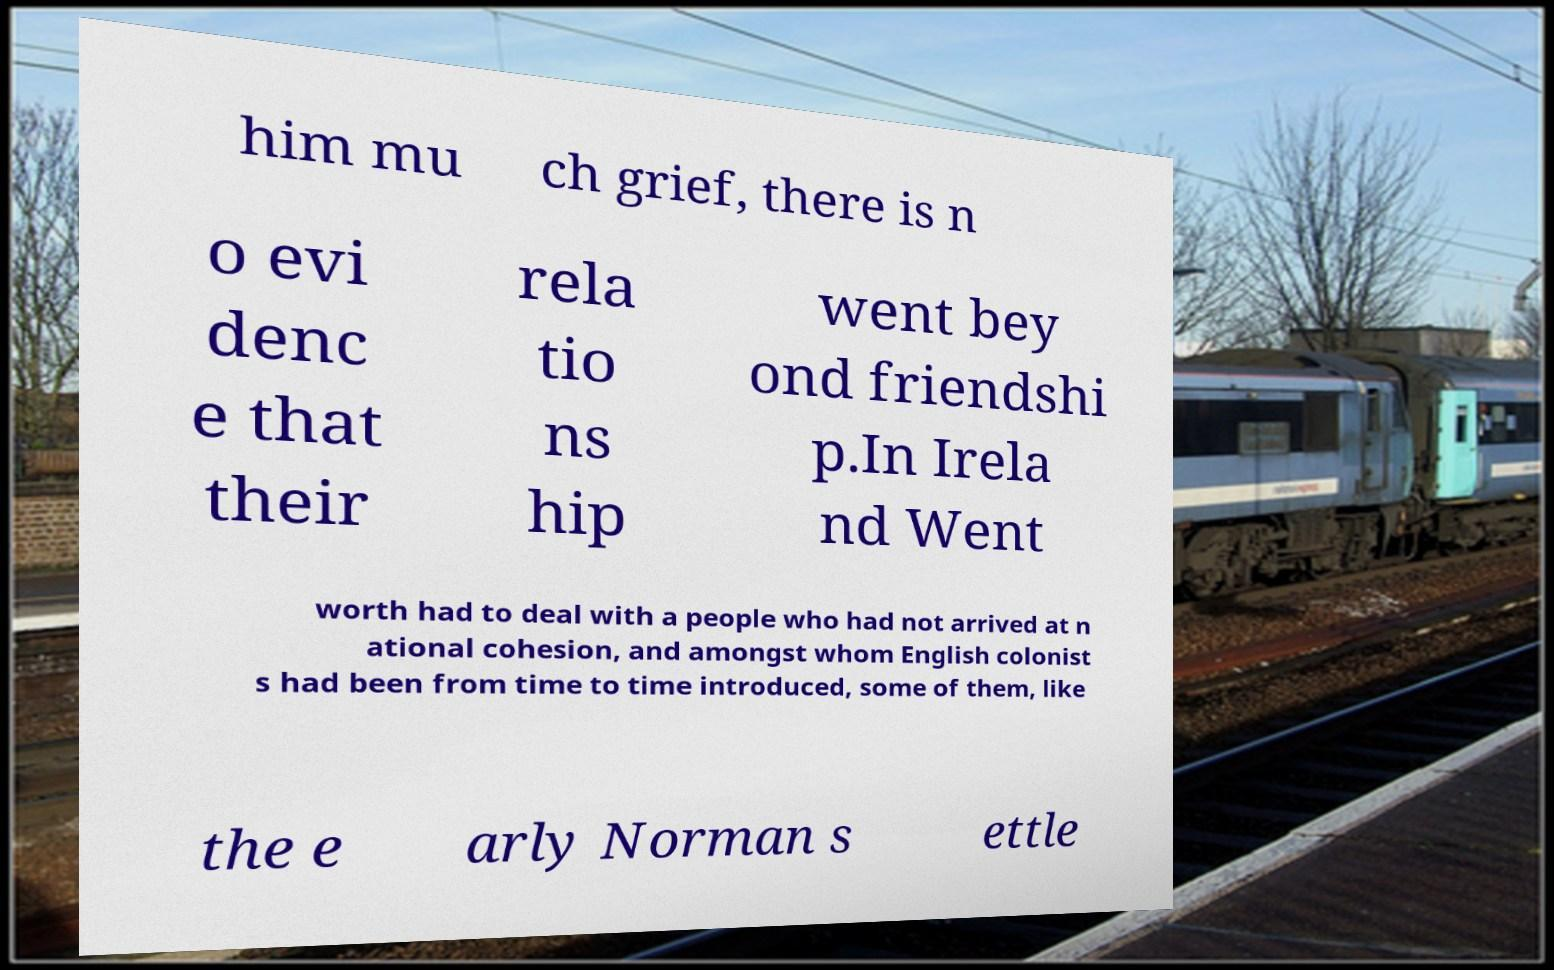For documentation purposes, I need the text within this image transcribed. Could you provide that? him mu ch grief, there is n o evi denc e that their rela tio ns hip went bey ond friendshi p.In Irela nd Went worth had to deal with a people who had not arrived at n ational cohesion, and amongst whom English colonist s had been from time to time introduced, some of them, like the e arly Norman s ettle 